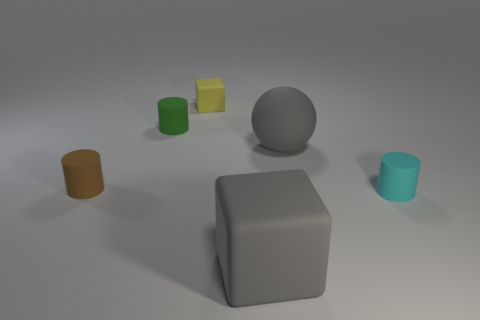What is the material of the thing that is the same size as the gray rubber cube?
Your response must be concise. Rubber. What is the material of the large gray object that is right of the cube in front of the block behind the brown thing?
Provide a short and direct response. Rubber. The big ball is what color?
Keep it short and to the point. Gray. What number of large objects are either matte balls or cyan rubber things?
Your response must be concise. 1. There is a large block that is the same color as the large matte sphere; what material is it?
Offer a terse response. Rubber. Are there any large matte blocks?
Offer a terse response. Yes. Is the number of large gray objects on the right side of the tiny green cylinder greater than the number of green rubber cylinders that are behind the tiny yellow matte cube?
Your answer should be very brief. Yes. There is a matte cube in front of the small yellow matte block; is its color the same as the big thing that is behind the tiny brown matte cylinder?
Provide a short and direct response. Yes. There is a small yellow object; what shape is it?
Your response must be concise. Cube. Are there more cyan things that are in front of the yellow block than brown metal spheres?
Provide a succinct answer. Yes. 